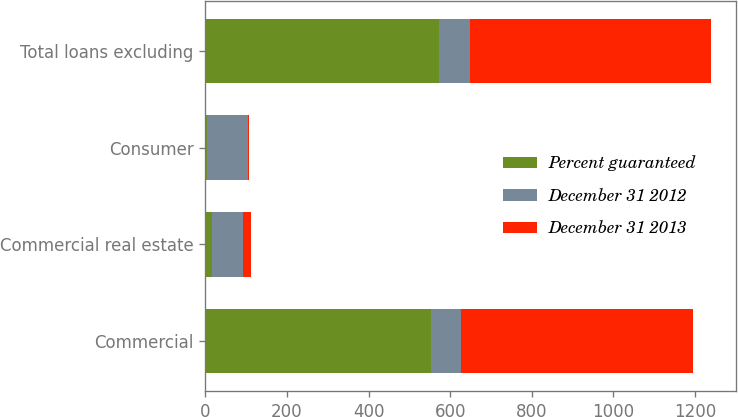Convert chart. <chart><loc_0><loc_0><loc_500><loc_500><stacked_bar_chart><ecel><fcel>Commercial<fcel>Commercial real estate<fcel>Consumer<fcel>Total loans excluding<nl><fcel>Percent guaranteed<fcel>552<fcel>17<fcel>4<fcel>573<nl><fcel>December 31 2012<fcel>75<fcel>76<fcel>100<fcel>76<nl><fcel>December 31 2013<fcel>567<fcel>20<fcel>3<fcel>590<nl></chart> 